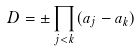<formula> <loc_0><loc_0><loc_500><loc_500>D = \pm \prod _ { j < k } ( a _ { j } - a _ { k } )</formula> 